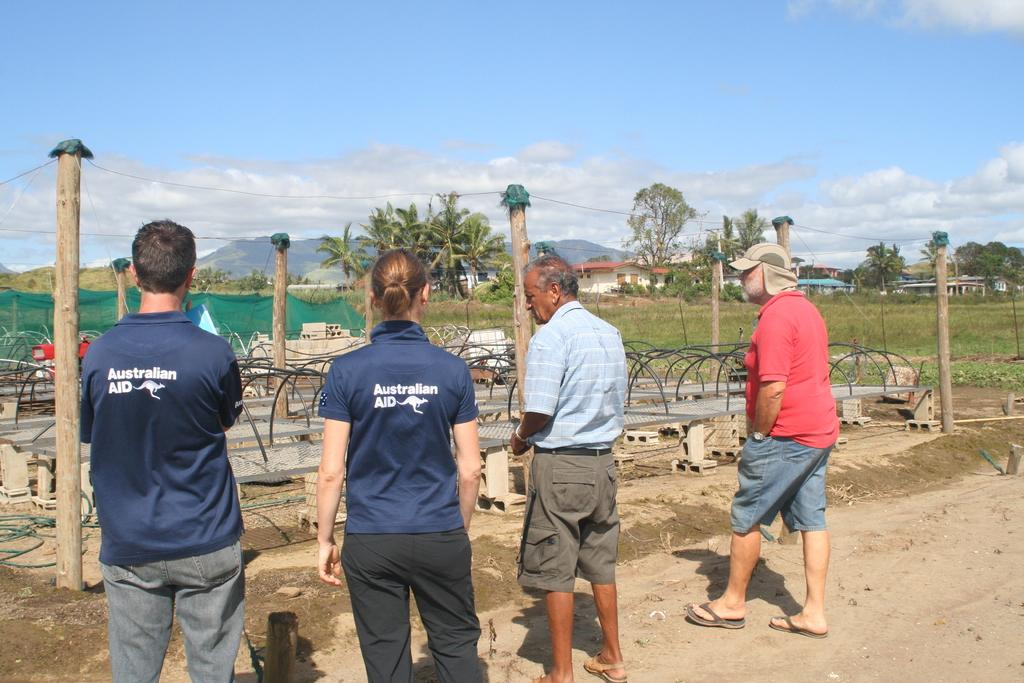How many people are in the image? There is a group of people in the image, but the exact number is not specified. What is the setting of the image? The people are standing on a path, and there are trees, plants, houses, and hills visible in the image. What are the wooden poles in front of the people used for? The purpose of the wooden poles is not specified in the image. What is the weather like in the image? The sky is cloudy in the image, which suggests a potentially overcast or rainy day. What type of paper is being used to play basketball in the image? There is no paper or basketball present in the image. 